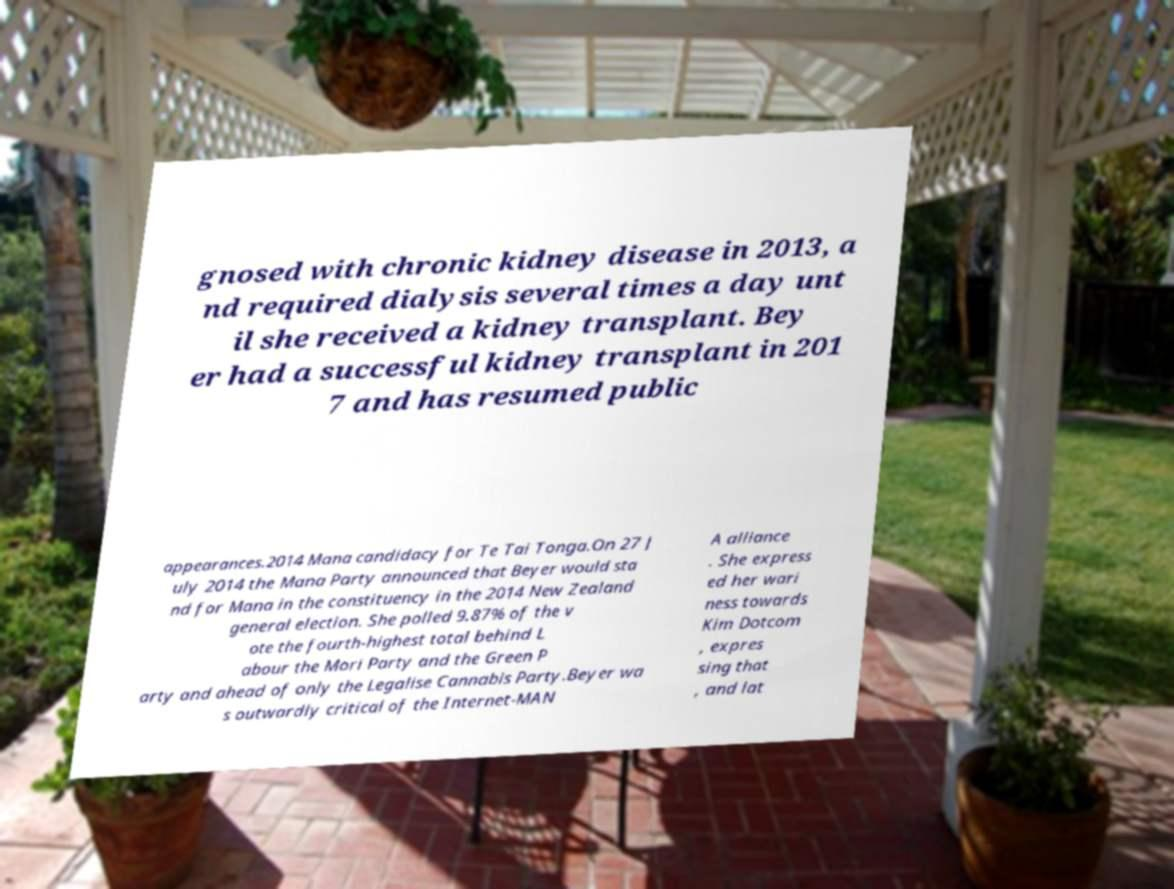What messages or text are displayed in this image? I need them in a readable, typed format. gnosed with chronic kidney disease in 2013, a nd required dialysis several times a day unt il she received a kidney transplant. Bey er had a successful kidney transplant in 201 7 and has resumed public appearances.2014 Mana candidacy for Te Tai Tonga.On 27 J uly 2014 the Mana Party announced that Beyer would sta nd for Mana in the constituency in the 2014 New Zealand general election. She polled 9.87% of the v ote the fourth-highest total behind L abour the Mori Party and the Green P arty and ahead of only the Legalise Cannabis Party.Beyer wa s outwardly critical of the Internet-MAN A alliance . She express ed her wari ness towards Kim Dotcom , expres sing that , and lat 